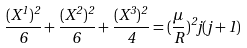<formula> <loc_0><loc_0><loc_500><loc_500>\frac { ( X ^ { 1 } ) ^ { 2 } } { 6 } + \frac { ( X ^ { 2 } ) ^ { 2 } } { 6 } + \frac { ( X ^ { 3 } ) ^ { 2 } } { 4 } = ( \frac { \mu } { R } ) ^ { 2 } j ( j + 1 )</formula> 